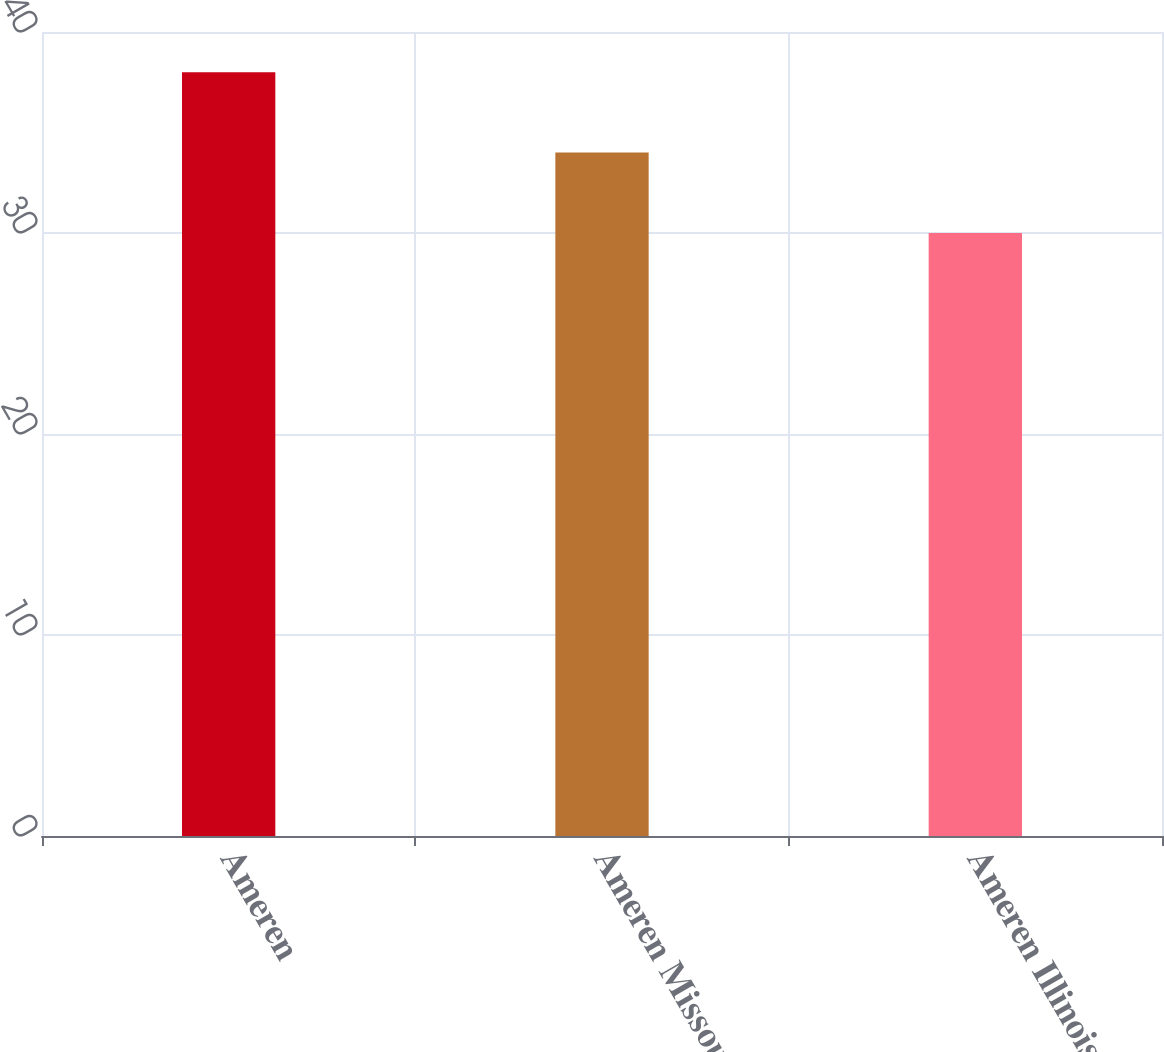<chart> <loc_0><loc_0><loc_500><loc_500><bar_chart><fcel>Ameren<fcel>Ameren Missouri<fcel>Ameren Illinois<nl><fcel>38<fcel>34<fcel>30<nl></chart> 